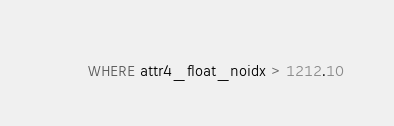Convert code to text. <code><loc_0><loc_0><loc_500><loc_500><_SQL_>        WHERE attr4_float_noidx > 1212.10</code> 